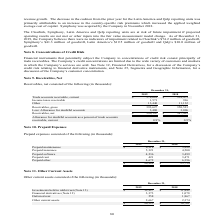According to Sykes Enterprises Incorporated's financial document, What was the amount of prepaid expenses in 2019? According to the financial document, $20,868 (in thousands). The relevant text states: "$ 20,868 $ 23,754..." Also, What was the amount of Prepaid maintenance in 2018? According to the financial document, $5,888 (in thousands). The relevant text states: "Prepaid maintenance $ 6,218 $ 5,888..." Also, What are the items considered under prepaid expenses in the table? The document contains multiple relevant values: Prepaid maintenance, Prepaid insurance, Prepaid software, Prepaid rent, Prepaid other. From the document: "Prepaid maintenance $ 6,218 $ 5,888 Prepaid insurance 5,321 4,500 Prepaid software 4,236 3,499 Prepaid rent 421 3,471 Prepaid other 4,672 6,396..." Additionally, In which year was the amount of prepaid insurance larger? According to the financial document, 2019. The relevant text states: "2019 2018..." Also, can you calculate: What was the change in prepaid insurance in 2019 from 2018? Based on the calculation: 5,321-4,500, the result is 821 (in thousands). This is based on the information: "Prepaid insurance 5,321 4,500 Prepaid insurance 5,321 4,500..." The key data points involved are: 4,500, 5,321. Also, can you calculate: What was the percentage change in prepaid insurance in 2019 from 2018? To answer this question, I need to perform calculations using the financial data. The calculation is: (5,321-4,500)/4,500, which equals 18.24 (percentage). This is based on the information: "Prepaid insurance 5,321 4,500 Prepaid insurance 5,321 4,500..." The key data points involved are: 4,500, 5,321. 